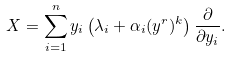<formula> <loc_0><loc_0><loc_500><loc_500>X = \sum _ { i = 1 } ^ { n } { y _ { i } \left ( \lambda _ { i } + \alpha _ { i } ( y ^ { r } ) ^ { k } \right ) \frac { \partial } { \partial y _ { i } } } .</formula> 